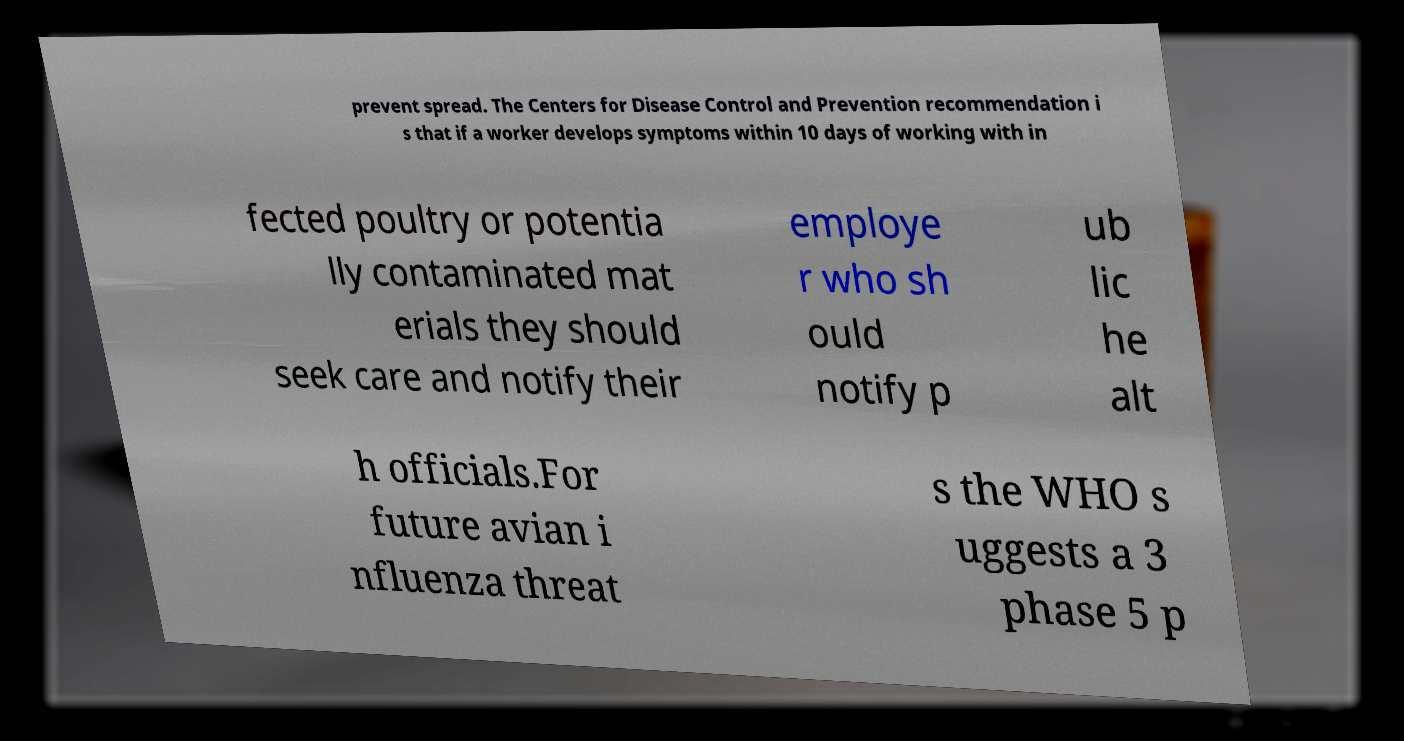Can you accurately transcribe the text from the provided image for me? prevent spread. The Centers for Disease Control and Prevention recommendation i s that if a worker develops symptoms within 10 days of working with in fected poultry or potentia lly contaminated mat erials they should seek care and notify their employe r who sh ould notify p ub lic he alt h officials.For future avian i nfluenza threat s the WHO s uggests a 3 phase 5 p 